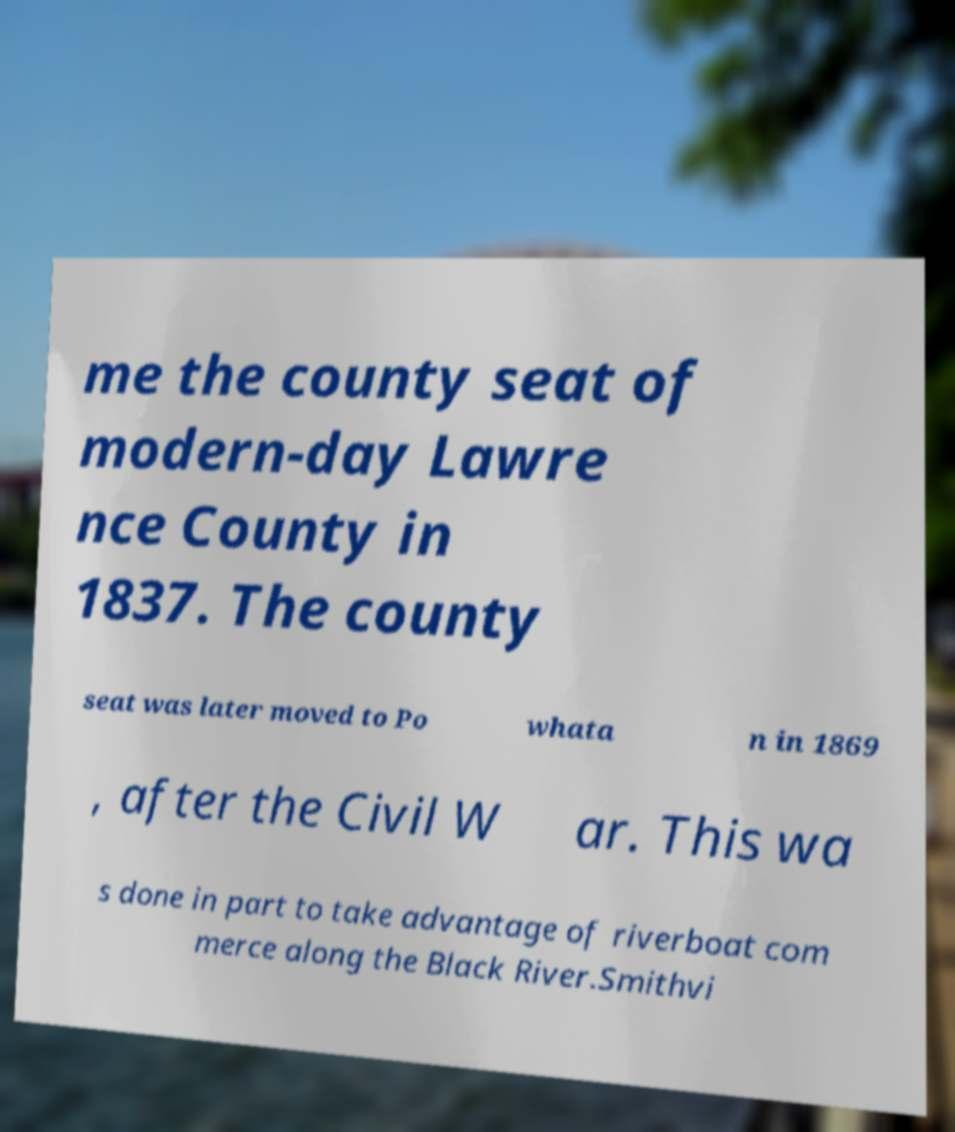There's text embedded in this image that I need extracted. Can you transcribe it verbatim? me the county seat of modern-day Lawre nce County in 1837. The county seat was later moved to Po whata n in 1869 , after the Civil W ar. This wa s done in part to take advantage of riverboat com merce along the Black River.Smithvi 